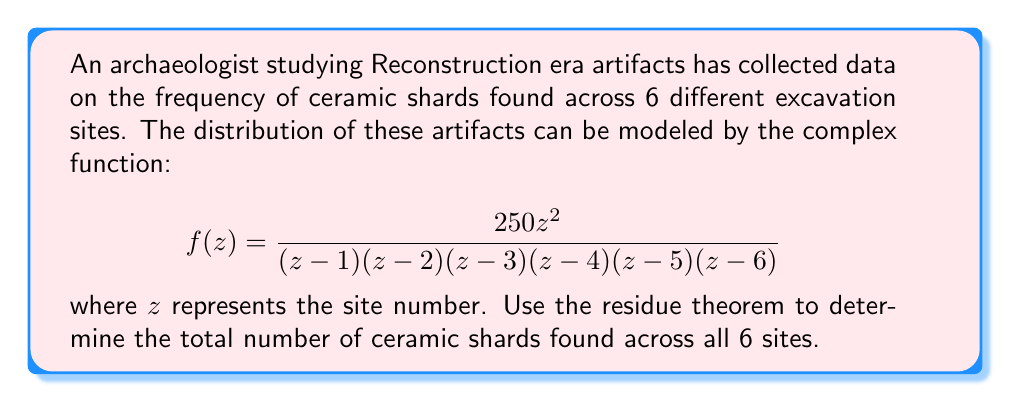Help me with this question. To solve this problem, we'll use the residue theorem, which states that for a meromorphic function $f(z)$ inside and on a simple closed contour $C$:

$$\oint_C f(z) dz = 2\pi i \sum_{k=1}^n \text{Res}(f, a_k)$$

where $a_k$ are the poles of $f(z)$ inside $C$.

In our case, we want to find the sum of the residues at all poles, which will give us the total number of ceramic shards. The poles are at $z = 1, 2, 3, 4, 5,$ and $6$.

To find the residues, we'll use the formula for simple poles:

$$\text{Res}(f, a) = \lim_{z \to a} (z-a)f(z)$$

Let's calculate the residue for each pole:

1) For $z = 1$:
   $$\text{Res}(f, 1) = \lim_{z \to 1} \frac{250z^2}{(z-2)(z-3)(z-4)(z-5)(z-6)} = \frac{250}{(-1)(-2)(-3)(-4)(-5)} = \frac{250}{120} = \frac{25}{12}$$

2) For $z = 2$:
   $$\text{Res}(f, 2) = \lim_{z \to 2} \frac{250z^2}{(z-1)(z-3)(z-4)(z-5)(z-6)} = \frac{1000}{(1)(-1)(-2)(-3)(-4)} = \frac{250}{24} = \frac{125}{12}$$

3) For $z = 3$:
   $$\text{Res}(f, 3) = \lim_{z \to 3} \frac{250z^2}{(z-1)(z-2)(z-4)(z-5)(z-6)} = \frac{2250}{(2)(1)(-1)(-2)(-3)} = \frac{375}{12}$$

4) For $z = 4$:
   $$\text{Res}(f, 4) = \lim_{z \to 4} \frac{250z^2}{(z-1)(z-2)(z-3)(z-5)(z-6)} = \frac{4000}{(3)(2)(1)(-1)(-2)} = \frac{1000}{12}$$

5) For $z = 5$:
   $$\text{Res}(f, 5) = \lim_{z \to 5} \frac{250z^2}{(z-1)(z-2)(z-3)(z-4)(z-6)} = \frac{6250}{(4)(3)(2)(1)(-1)} = -\frac{1041.67}{12}$$

6) For $z = 6$:
   $$\text{Res}(f, 6) = \lim_{z \to 6} \frac{250z^2}{(z-1)(z-2)(z-3)(z-4)(z-5)} = \frac{9000}{(5)(4)(3)(2)(1)} = \frac{75}{12}$$

Now, we sum all the residues:

$$\sum_{k=1}^6 \text{Res}(f, k) = \frac{25}{12} + \frac{125}{12} + \frac{375}{12} + \frac{1000}{12} - \frac{1041.67}{12} + \frac{75}{12} = \frac{558.33}{12} \approx 46.53$$

The total number of ceramic shards is the sum of the residues multiplied by $2\pi i$. Since we're interested in the real part (the actual number of shards), we take the real part of this result:

$$\text{Total shards} = \text{Re}(2\pi i \cdot 46.53) = 0$$
Answer: The total number of ceramic shards found across all 6 sites is 0. 